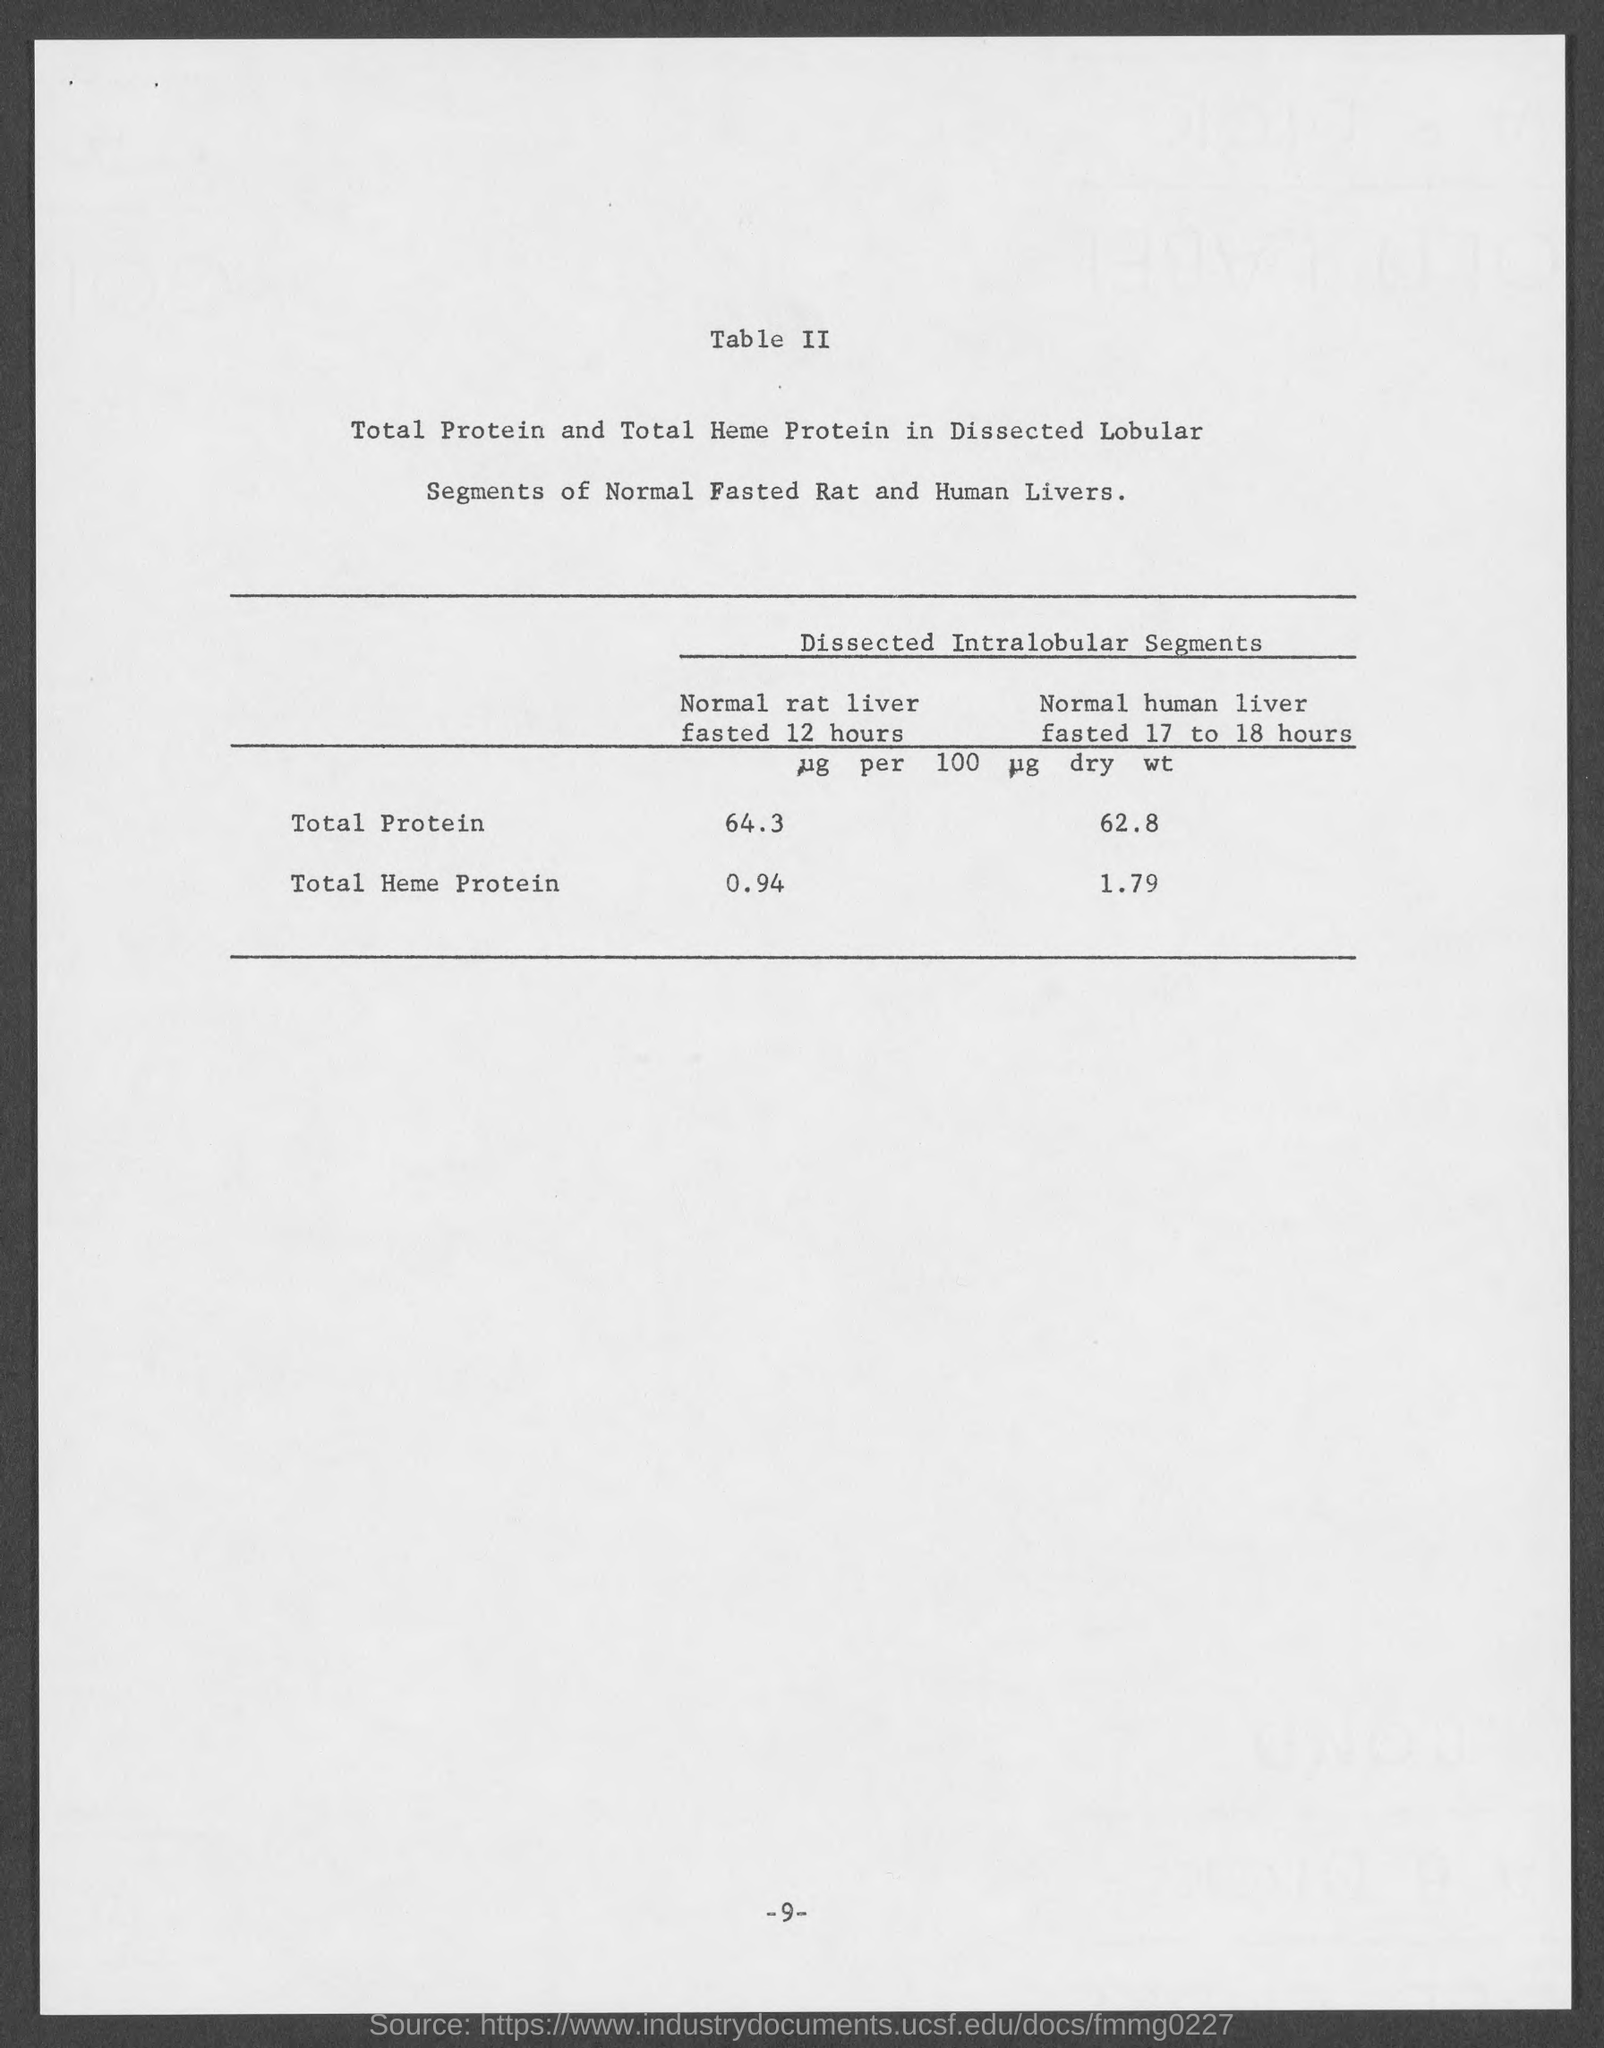Identify some key points in this picture. The total amount of heme protein in a normal human liver that has been fasted for 17 to 18 hours is 1.79. The total amount of protein in a normal rat liver that has been fasted for 12 hours is 64.3. 